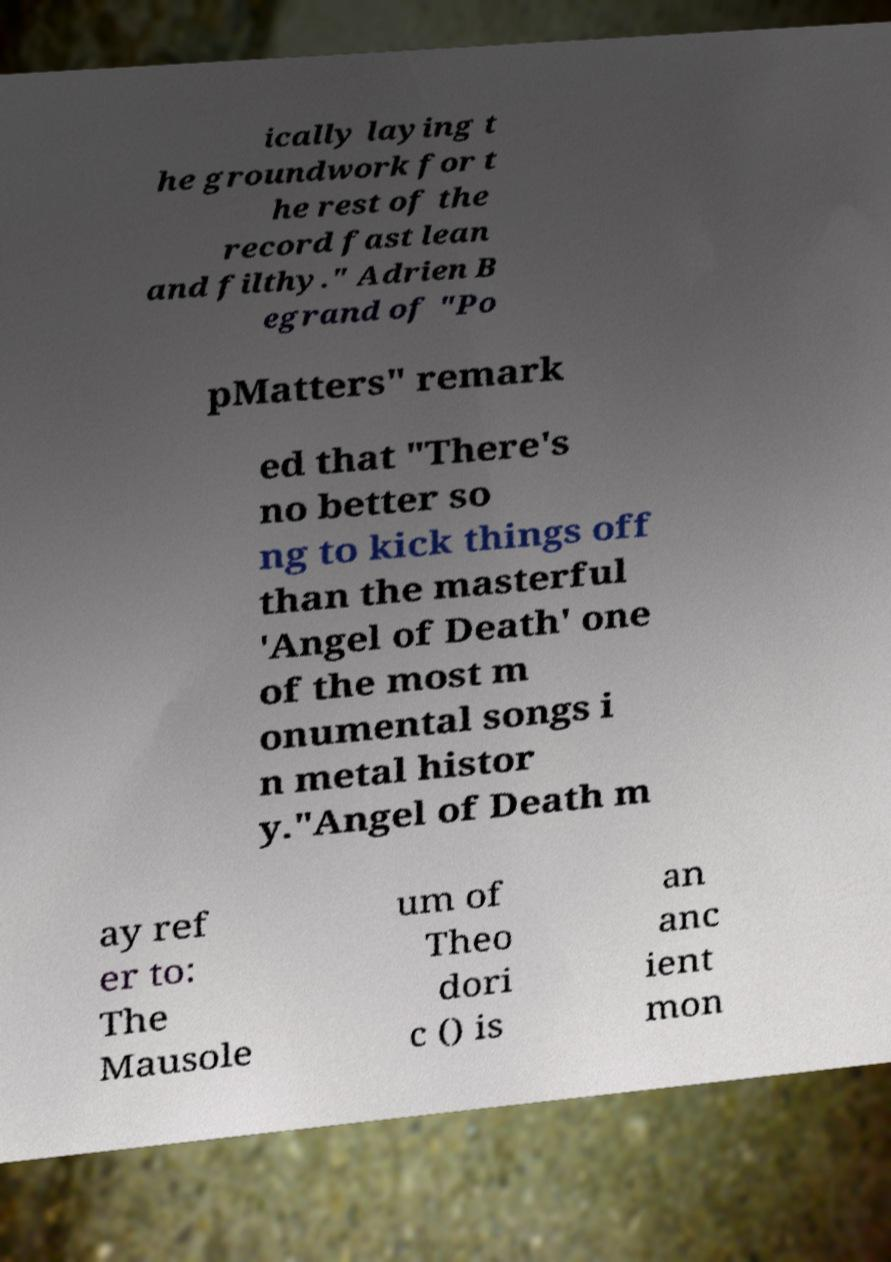For documentation purposes, I need the text within this image transcribed. Could you provide that? ically laying t he groundwork for t he rest of the record fast lean and filthy." Adrien B egrand of "Po pMatters" remark ed that "There's no better so ng to kick things off than the masterful 'Angel of Death' one of the most m onumental songs i n metal histor y."Angel of Death m ay ref er to: The Mausole um of Theo dori c () is an anc ient mon 